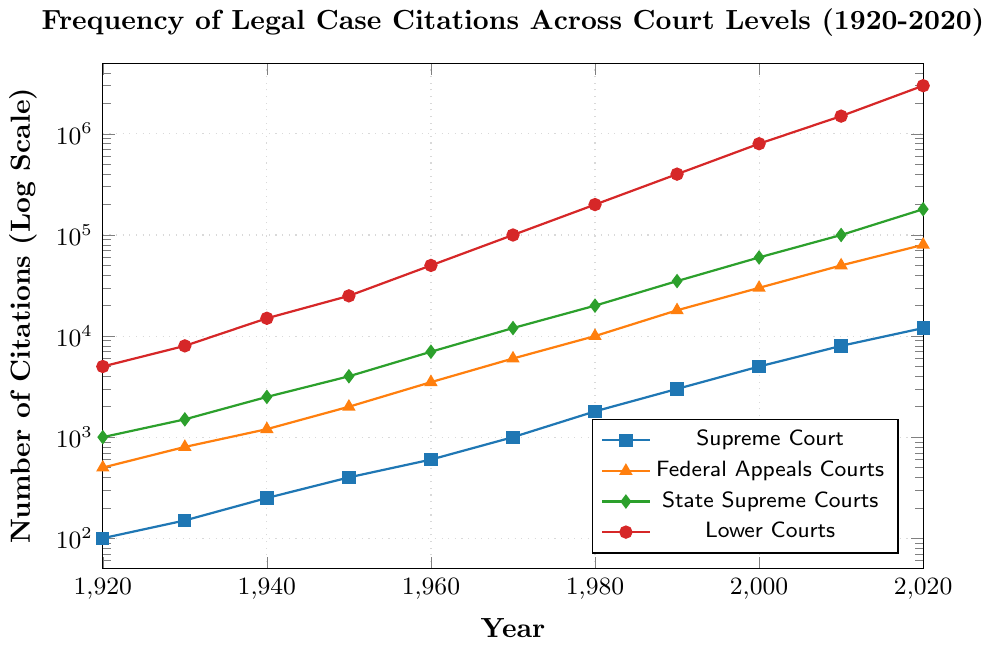What's the range of citations for the State Supreme Courts in the depicted period? The lowest number of citations for State Supreme Courts in the chart is 1,000 in 1920, and the highest is 180,000 in 2020. Thus, the range is the difference between these two values: 180,000 - 1,000 = 179,000.
Answer: 179,000 Compare the frequency of citations between the Supreme Court and Lower Courts in 1960. In 1960, the Supreme Court had 600 citations, and the Lower Courts had 50,000. To find which is higher, compare the two values directly: 50,000 is greater than 600.
Answer: Lower Courts Which court shows the steepest growth in citations from 1980 to 1990? To determine this, calculate the difference in citations for each court between 1980 and 1990. Supreme Court: 3000 - 1800 = 1200, Federal Appeals Courts: 18000 - 10000 = 8000, State Supreme Courts: 35000 - 20000 = 15000, Lower Courts: 400000 - 200000 = 200000. The Lower Courts show the steepest growth (200000).
Answer: Lower Courts How many citations did the Federal Appeals Courts have in 2020? Locate the Federal Appeals Courts data series and identify the 2020 value: It is 80,000 citations.
Answer: 80,000 If the number of Supreme Court citations in 1940 is represented by a blue square, what shape and color represent the number of Lower Courts citations in the same year? The Lower Courts are represented using a red circle.
Answer: Red circle Calculate the average number of citations for the Federal Appeals Courts in the decades represented in the chart. First, sum all the citations for Federal Appeals Courts: 500 + 800 + 1200 + 2000 + 3500 + 6000 + 10000 + 18000 + 30000 + 50000 + 80000 = 207,000. There are 11 data points (decades), so the average is 207,000 / 11 ≈ 18,818.
Answer: 18,818 Which court had the lowest number of citations in 2020, and how many? In 2020, read the values for all courts: Supreme Court: 12,000, Federal Appeals Courts: 80,000, State Supreme Courts: 180,000, Lower Courts: 3,000,000. The Supreme Court had the lowest number of citations at 12,000.
Answer: Supreme Court, 12,000 